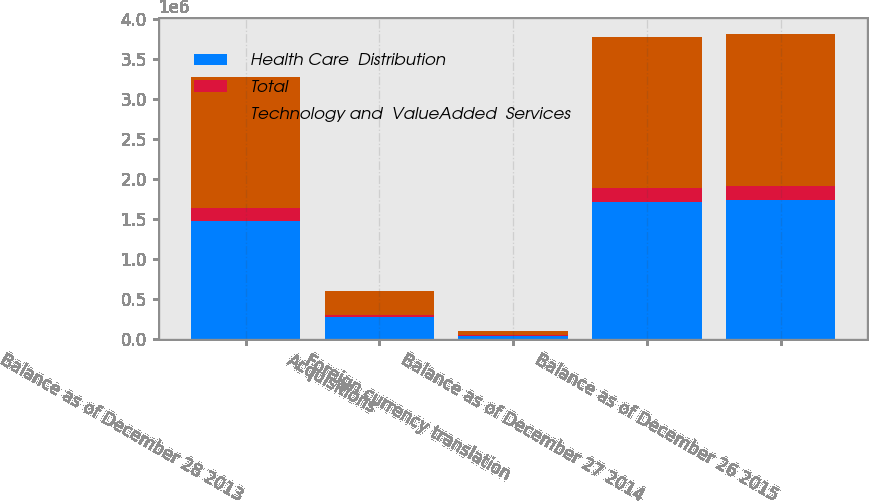Convert chart to OTSL. <chart><loc_0><loc_0><loc_500><loc_500><stacked_bar_chart><ecel><fcel>Balance as of December 28 2013<fcel>Acquisitions<fcel>Foreign currency translation<fcel>Balance as of December 27 2014<fcel>Balance as of December 26 2015<nl><fcel>Health Care  Distribution<fcel>1.47918e+06<fcel>279400<fcel>48023<fcel>1.71055e+06<fcel>1.74202e+06<nl><fcel>Total<fcel>155828<fcel>24457<fcel>6716<fcel>173569<fcel>165571<nl><fcel>Technology and  ValueAdded  Services<fcel>1.635e+06<fcel>303857<fcel>54739<fcel>1.88412e+06<fcel>1.90759e+06<nl></chart> 